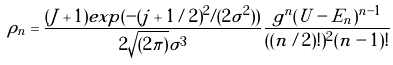Convert formula to latex. <formula><loc_0><loc_0><loc_500><loc_500>\rho _ { n } = \frac { ( J + 1 ) e x p ( - ( j + 1 / 2 ) ^ { 2 } / ( 2 \sigma ^ { 2 } ) ) } { 2 \sqrt { ( 2 \pi ) } \sigma ^ { 3 } } \frac { g ^ { n } ( U - E _ { n } ) ^ { n - 1 } } { ( ( n / 2 ) ! ) ^ { 2 } ( n - 1 ) ! }</formula> 